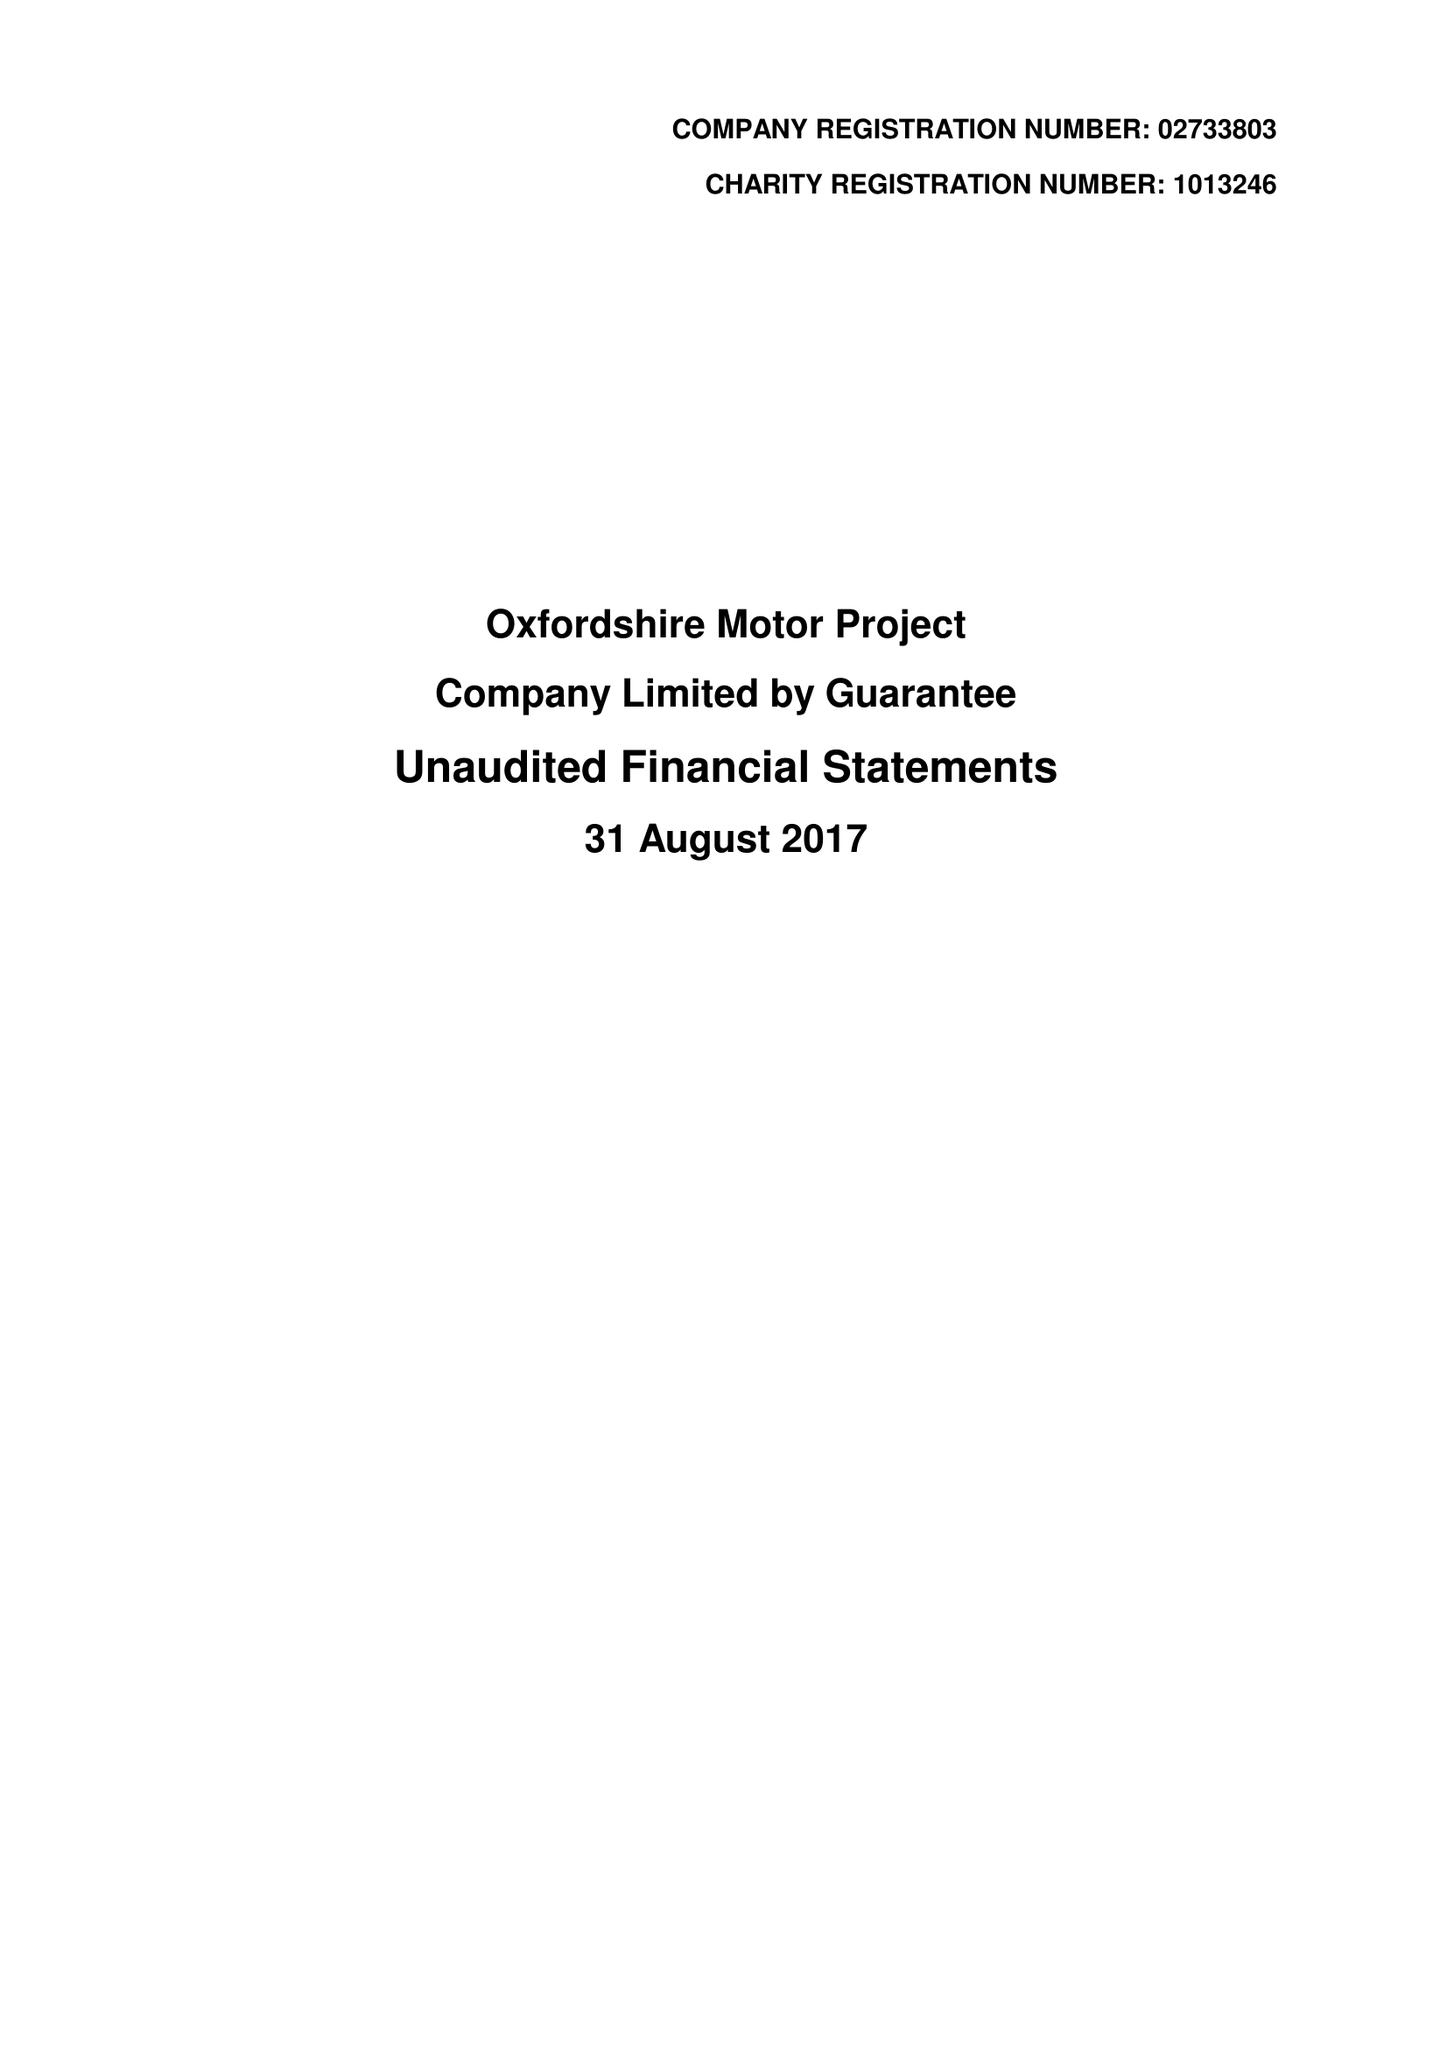What is the value for the report_date?
Answer the question using a single word or phrase. 2017-08-31 